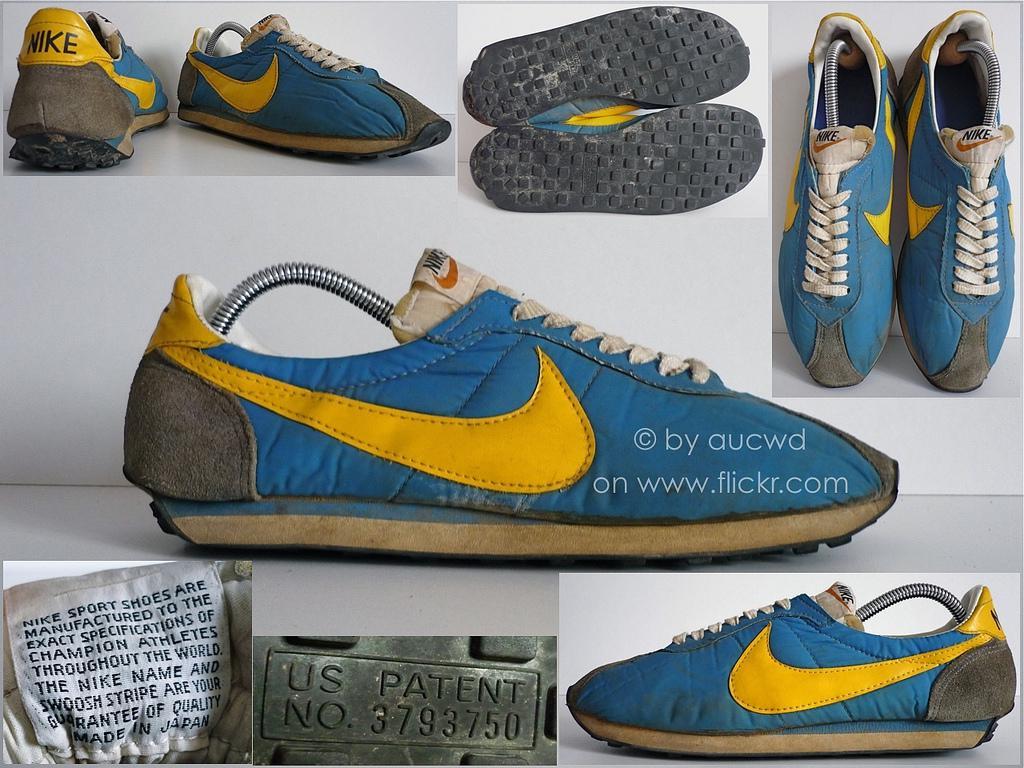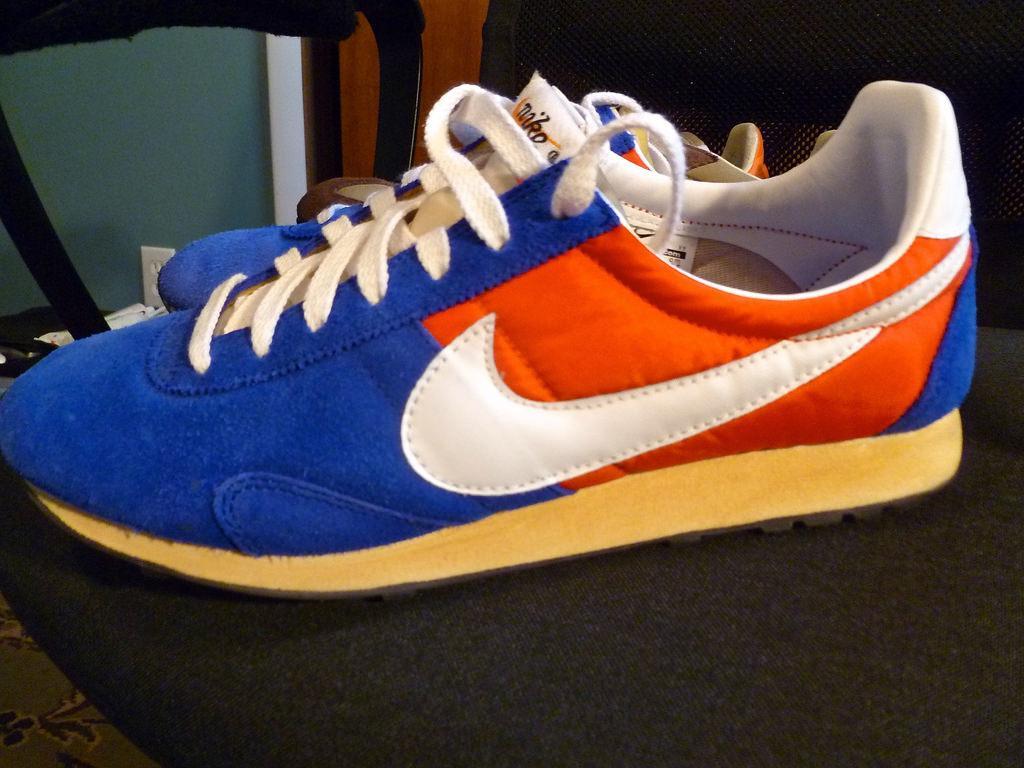The first image is the image on the left, the second image is the image on the right. Considering the images on both sides, is "Every shoe is posed facing directly leftward, and one image contains a single shoe." valid? Answer yes or no. No. The first image is the image on the left, the second image is the image on the right. Considering the images on both sides, is "The left image contains no more than one shoe." valid? Answer yes or no. No. 